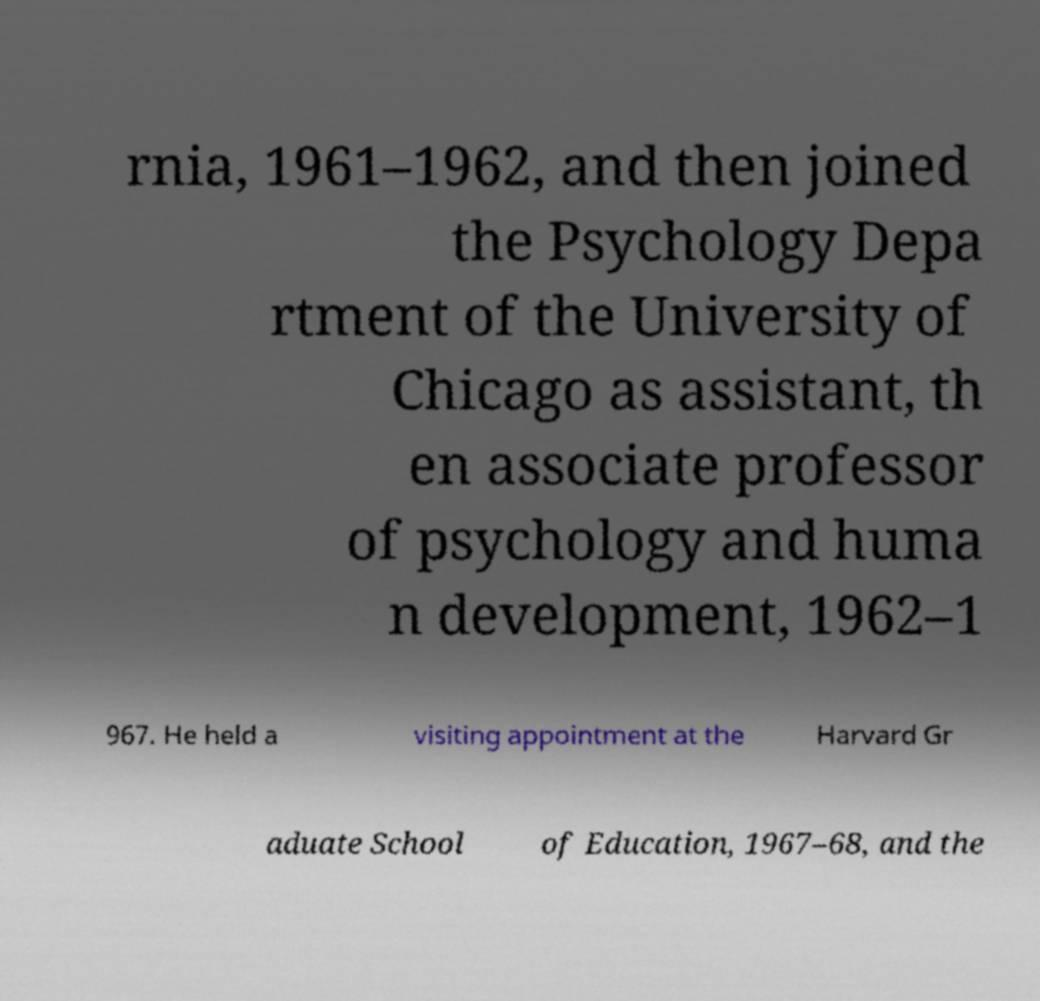Could you assist in decoding the text presented in this image and type it out clearly? rnia, 1961–1962, and then joined the Psychology Depa rtment of the University of Chicago as assistant, th en associate professor of psychology and huma n development, 1962–1 967. He held a visiting appointment at the Harvard Gr aduate School of Education, 1967–68, and the 